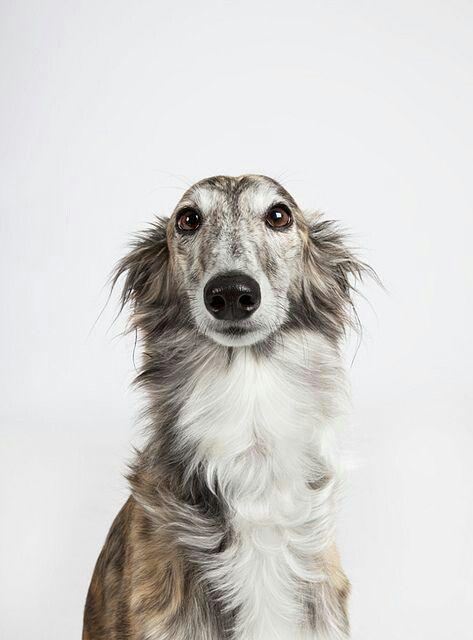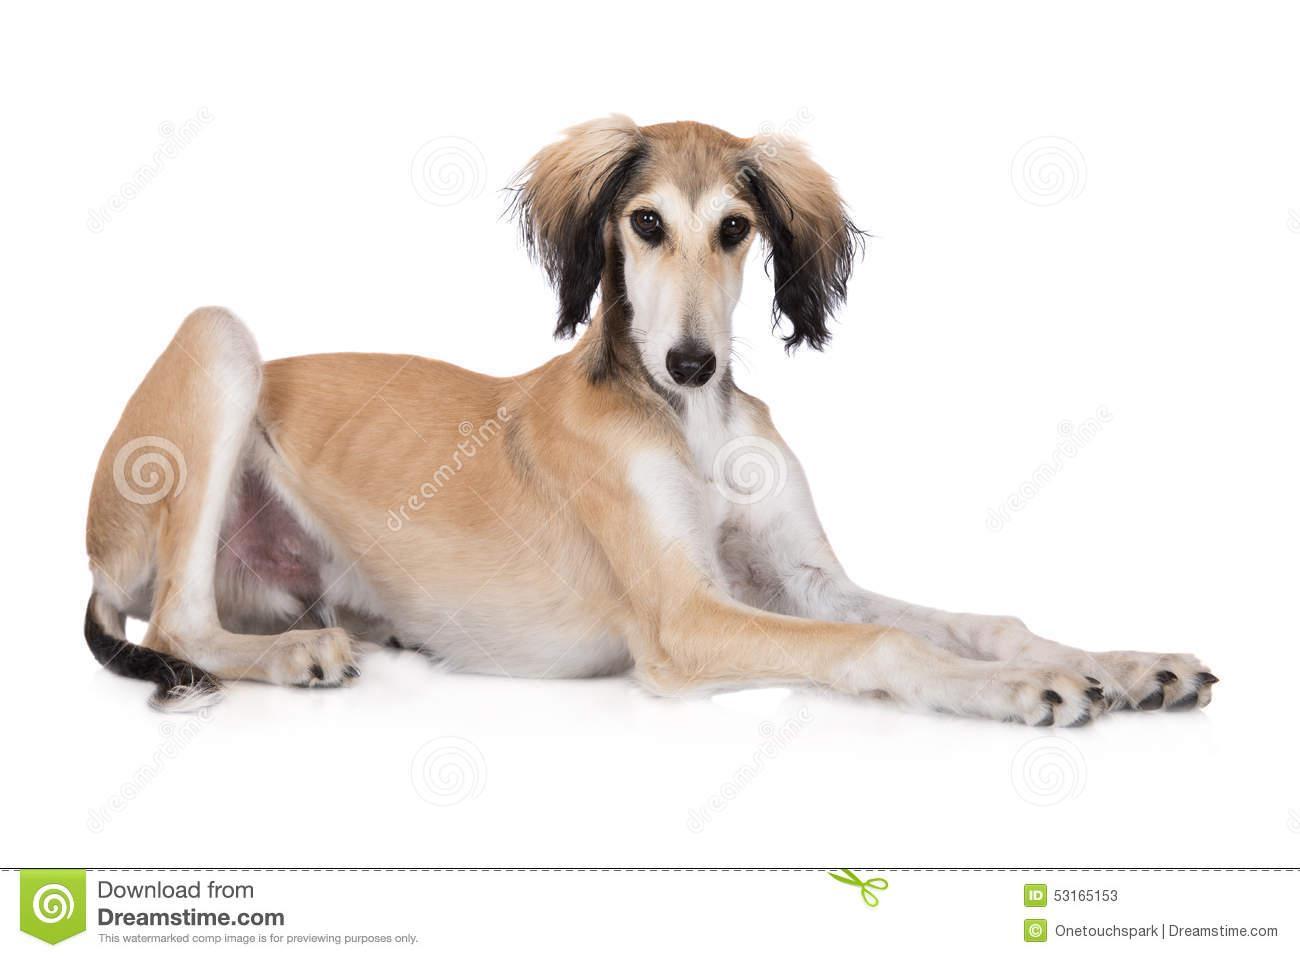The first image is the image on the left, the second image is the image on the right. Assess this claim about the two images: "The dog in the image on the right is lying down.". Correct or not? Answer yes or no. Yes. The first image is the image on the left, the second image is the image on the right. For the images displayed, is the sentence "Each image contains a single hound dog, and one image shows a dog in a reclining position with both front paws extended forward." factually correct? Answer yes or no. Yes. 